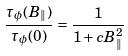Convert formula to latex. <formula><loc_0><loc_0><loc_500><loc_500>\frac { \tau _ { \phi } ( B _ { \| } ) } { \tau _ { \phi } ( 0 ) } = \frac { 1 } { 1 + c B _ { \| } ^ { 2 } }</formula> 